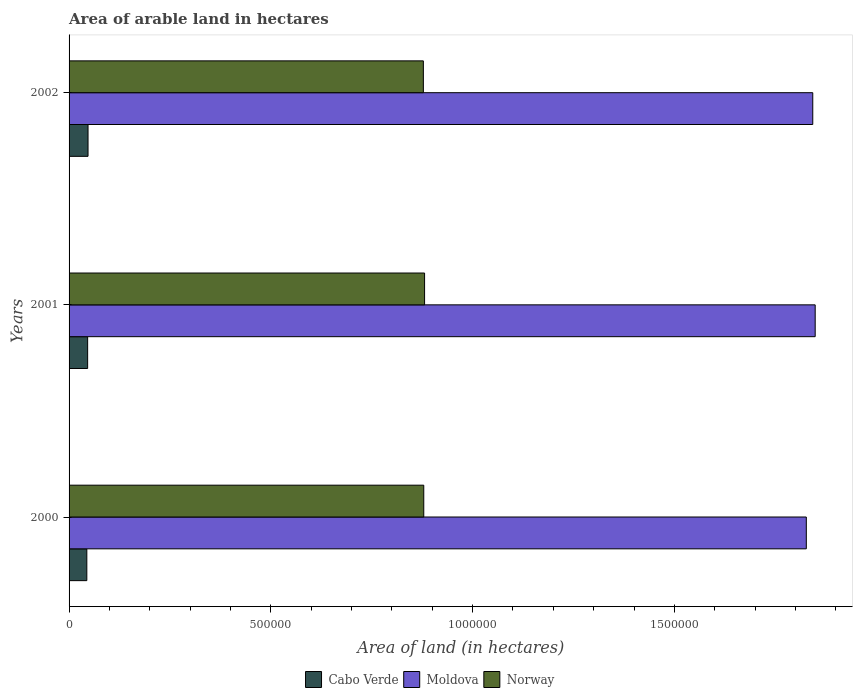How many bars are there on the 3rd tick from the bottom?
Offer a terse response. 3. In how many cases, is the number of bars for a given year not equal to the number of legend labels?
Provide a succinct answer. 0. What is the total arable land in Cabo Verde in 2001?
Give a very brief answer. 4.60e+04. Across all years, what is the maximum total arable land in Cabo Verde?
Offer a very short reply. 4.70e+04. Across all years, what is the minimum total arable land in Cabo Verde?
Give a very brief answer. 4.40e+04. What is the total total arable land in Norway in the graph?
Your answer should be very brief. 2.64e+06. What is the difference between the total arable land in Cabo Verde in 2000 and that in 2001?
Your response must be concise. -2000. What is the difference between the total arable land in Norway in 2000 and the total arable land in Cabo Verde in 2001?
Your answer should be compact. 8.33e+05. What is the average total arable land in Cabo Verde per year?
Give a very brief answer. 4.57e+04. In the year 2001, what is the difference between the total arable land in Norway and total arable land in Cabo Verde?
Provide a short and direct response. 8.35e+05. In how many years, is the total arable land in Norway greater than 1400000 hectares?
Give a very brief answer. 0. What is the ratio of the total arable land in Cabo Verde in 2001 to that in 2002?
Your answer should be very brief. 0.98. Is the total arable land in Norway in 2000 less than that in 2002?
Provide a succinct answer. No. What is the difference between the highest and the second highest total arable land in Norway?
Keep it short and to the point. 2000. What is the difference between the highest and the lowest total arable land in Norway?
Provide a succinct answer. 3000. In how many years, is the total arable land in Cabo Verde greater than the average total arable land in Cabo Verde taken over all years?
Your response must be concise. 2. What does the 3rd bar from the top in 2002 represents?
Keep it short and to the point. Cabo Verde. Are all the bars in the graph horizontal?
Make the answer very short. Yes. How many years are there in the graph?
Provide a succinct answer. 3. Does the graph contain any zero values?
Provide a succinct answer. No. How many legend labels are there?
Your response must be concise. 3. What is the title of the graph?
Make the answer very short. Area of arable land in hectares. Does "Aruba" appear as one of the legend labels in the graph?
Give a very brief answer. No. What is the label or title of the X-axis?
Offer a very short reply. Area of land (in hectares). What is the label or title of the Y-axis?
Keep it short and to the point. Years. What is the Area of land (in hectares) in Cabo Verde in 2000?
Provide a succinct answer. 4.40e+04. What is the Area of land (in hectares) in Moldova in 2000?
Offer a terse response. 1.83e+06. What is the Area of land (in hectares) of Norway in 2000?
Ensure brevity in your answer.  8.79e+05. What is the Area of land (in hectares) in Cabo Verde in 2001?
Your answer should be compact. 4.60e+04. What is the Area of land (in hectares) in Moldova in 2001?
Provide a succinct answer. 1.85e+06. What is the Area of land (in hectares) in Norway in 2001?
Your response must be concise. 8.81e+05. What is the Area of land (in hectares) of Cabo Verde in 2002?
Provide a succinct answer. 4.70e+04. What is the Area of land (in hectares) of Moldova in 2002?
Provide a short and direct response. 1.84e+06. What is the Area of land (in hectares) in Norway in 2002?
Your answer should be very brief. 8.78e+05. Across all years, what is the maximum Area of land (in hectares) in Cabo Verde?
Give a very brief answer. 4.70e+04. Across all years, what is the maximum Area of land (in hectares) of Moldova?
Your answer should be very brief. 1.85e+06. Across all years, what is the maximum Area of land (in hectares) of Norway?
Keep it short and to the point. 8.81e+05. Across all years, what is the minimum Area of land (in hectares) in Cabo Verde?
Your answer should be very brief. 4.40e+04. Across all years, what is the minimum Area of land (in hectares) in Moldova?
Give a very brief answer. 1.83e+06. Across all years, what is the minimum Area of land (in hectares) of Norway?
Keep it short and to the point. 8.78e+05. What is the total Area of land (in hectares) of Cabo Verde in the graph?
Offer a very short reply. 1.37e+05. What is the total Area of land (in hectares) of Moldova in the graph?
Give a very brief answer. 5.52e+06. What is the total Area of land (in hectares) in Norway in the graph?
Your answer should be compact. 2.64e+06. What is the difference between the Area of land (in hectares) in Cabo Verde in 2000 and that in 2001?
Give a very brief answer. -2000. What is the difference between the Area of land (in hectares) in Moldova in 2000 and that in 2001?
Give a very brief answer. -2.20e+04. What is the difference between the Area of land (in hectares) in Norway in 2000 and that in 2001?
Offer a very short reply. -2000. What is the difference between the Area of land (in hectares) of Cabo Verde in 2000 and that in 2002?
Your answer should be very brief. -3000. What is the difference between the Area of land (in hectares) in Moldova in 2000 and that in 2002?
Provide a succinct answer. -1.60e+04. What is the difference between the Area of land (in hectares) of Norway in 2000 and that in 2002?
Offer a terse response. 1000. What is the difference between the Area of land (in hectares) in Cabo Verde in 2001 and that in 2002?
Provide a succinct answer. -1000. What is the difference between the Area of land (in hectares) in Moldova in 2001 and that in 2002?
Ensure brevity in your answer.  6000. What is the difference between the Area of land (in hectares) in Norway in 2001 and that in 2002?
Your answer should be compact. 3000. What is the difference between the Area of land (in hectares) of Cabo Verde in 2000 and the Area of land (in hectares) of Moldova in 2001?
Offer a very short reply. -1.80e+06. What is the difference between the Area of land (in hectares) of Cabo Verde in 2000 and the Area of land (in hectares) of Norway in 2001?
Your response must be concise. -8.37e+05. What is the difference between the Area of land (in hectares) in Moldova in 2000 and the Area of land (in hectares) in Norway in 2001?
Keep it short and to the point. 9.46e+05. What is the difference between the Area of land (in hectares) of Cabo Verde in 2000 and the Area of land (in hectares) of Moldova in 2002?
Offer a very short reply. -1.80e+06. What is the difference between the Area of land (in hectares) of Cabo Verde in 2000 and the Area of land (in hectares) of Norway in 2002?
Offer a terse response. -8.34e+05. What is the difference between the Area of land (in hectares) in Moldova in 2000 and the Area of land (in hectares) in Norway in 2002?
Your response must be concise. 9.49e+05. What is the difference between the Area of land (in hectares) of Cabo Verde in 2001 and the Area of land (in hectares) of Moldova in 2002?
Your answer should be very brief. -1.80e+06. What is the difference between the Area of land (in hectares) in Cabo Verde in 2001 and the Area of land (in hectares) in Norway in 2002?
Provide a short and direct response. -8.32e+05. What is the difference between the Area of land (in hectares) of Moldova in 2001 and the Area of land (in hectares) of Norway in 2002?
Keep it short and to the point. 9.71e+05. What is the average Area of land (in hectares) of Cabo Verde per year?
Offer a terse response. 4.57e+04. What is the average Area of land (in hectares) in Moldova per year?
Provide a short and direct response. 1.84e+06. What is the average Area of land (in hectares) in Norway per year?
Offer a very short reply. 8.79e+05. In the year 2000, what is the difference between the Area of land (in hectares) in Cabo Verde and Area of land (in hectares) in Moldova?
Provide a short and direct response. -1.78e+06. In the year 2000, what is the difference between the Area of land (in hectares) of Cabo Verde and Area of land (in hectares) of Norway?
Provide a short and direct response. -8.35e+05. In the year 2000, what is the difference between the Area of land (in hectares) in Moldova and Area of land (in hectares) in Norway?
Offer a terse response. 9.48e+05. In the year 2001, what is the difference between the Area of land (in hectares) of Cabo Verde and Area of land (in hectares) of Moldova?
Offer a very short reply. -1.80e+06. In the year 2001, what is the difference between the Area of land (in hectares) of Cabo Verde and Area of land (in hectares) of Norway?
Offer a terse response. -8.35e+05. In the year 2001, what is the difference between the Area of land (in hectares) of Moldova and Area of land (in hectares) of Norway?
Give a very brief answer. 9.68e+05. In the year 2002, what is the difference between the Area of land (in hectares) in Cabo Verde and Area of land (in hectares) in Moldova?
Provide a short and direct response. -1.80e+06. In the year 2002, what is the difference between the Area of land (in hectares) in Cabo Verde and Area of land (in hectares) in Norway?
Ensure brevity in your answer.  -8.31e+05. In the year 2002, what is the difference between the Area of land (in hectares) in Moldova and Area of land (in hectares) in Norway?
Your answer should be compact. 9.65e+05. What is the ratio of the Area of land (in hectares) in Cabo Verde in 2000 to that in 2001?
Provide a succinct answer. 0.96. What is the ratio of the Area of land (in hectares) of Moldova in 2000 to that in 2001?
Provide a short and direct response. 0.99. What is the ratio of the Area of land (in hectares) of Cabo Verde in 2000 to that in 2002?
Your answer should be compact. 0.94. What is the ratio of the Area of land (in hectares) in Moldova in 2000 to that in 2002?
Ensure brevity in your answer.  0.99. What is the ratio of the Area of land (in hectares) in Cabo Verde in 2001 to that in 2002?
Ensure brevity in your answer.  0.98. What is the ratio of the Area of land (in hectares) of Moldova in 2001 to that in 2002?
Provide a succinct answer. 1. What is the ratio of the Area of land (in hectares) in Norway in 2001 to that in 2002?
Provide a short and direct response. 1. What is the difference between the highest and the second highest Area of land (in hectares) of Cabo Verde?
Ensure brevity in your answer.  1000. What is the difference between the highest and the second highest Area of land (in hectares) of Moldova?
Offer a terse response. 6000. What is the difference between the highest and the second highest Area of land (in hectares) of Norway?
Your answer should be very brief. 2000. What is the difference between the highest and the lowest Area of land (in hectares) in Cabo Verde?
Provide a short and direct response. 3000. What is the difference between the highest and the lowest Area of land (in hectares) in Moldova?
Provide a short and direct response. 2.20e+04. What is the difference between the highest and the lowest Area of land (in hectares) in Norway?
Make the answer very short. 3000. 